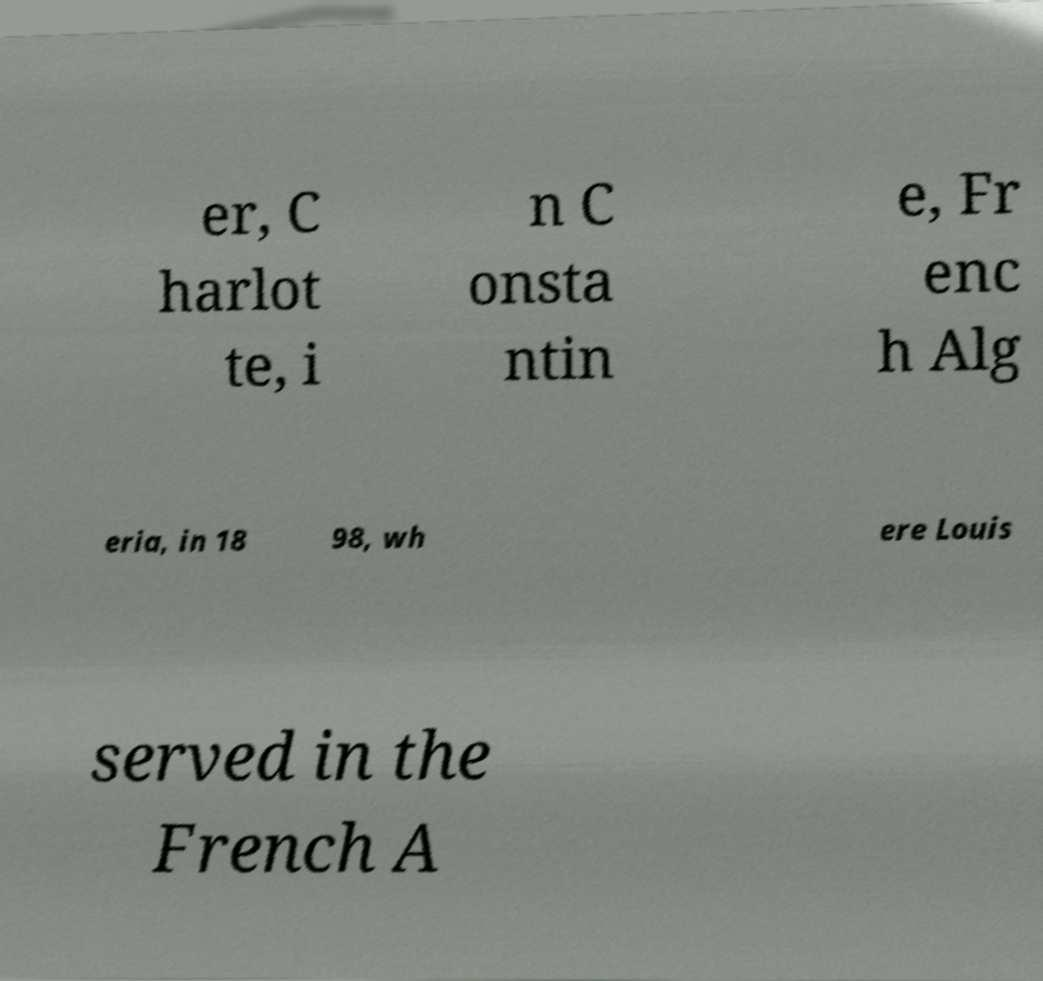Could you assist in decoding the text presented in this image and type it out clearly? er, C harlot te, i n C onsta ntin e, Fr enc h Alg eria, in 18 98, wh ere Louis served in the French A 